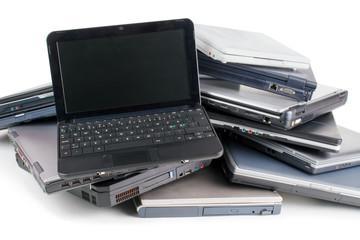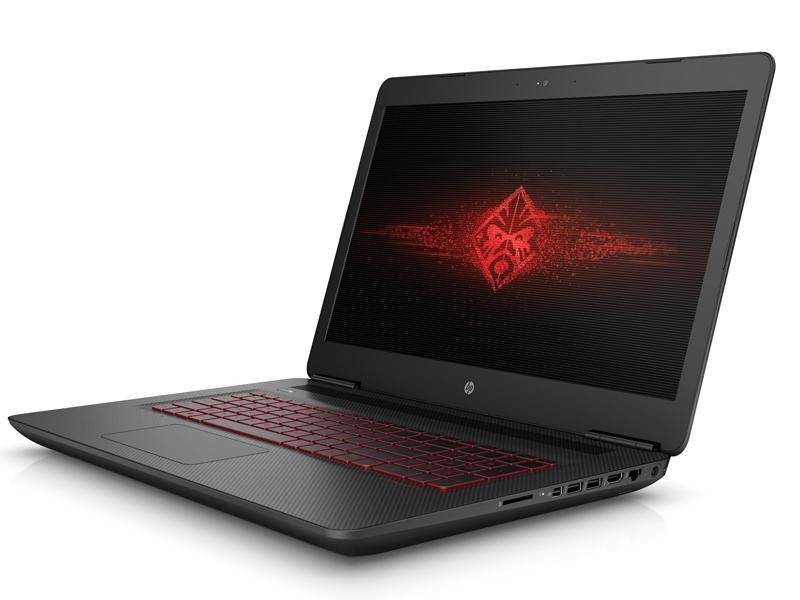The first image is the image on the left, the second image is the image on the right. Given the left and right images, does the statement "There are 3 or more books being displayed with laptops." hold true? Answer yes or no. No. The first image is the image on the left, the second image is the image on the right. Assess this claim about the two images: "There is one computer mouse in these.". Correct or not? Answer yes or no. No. 